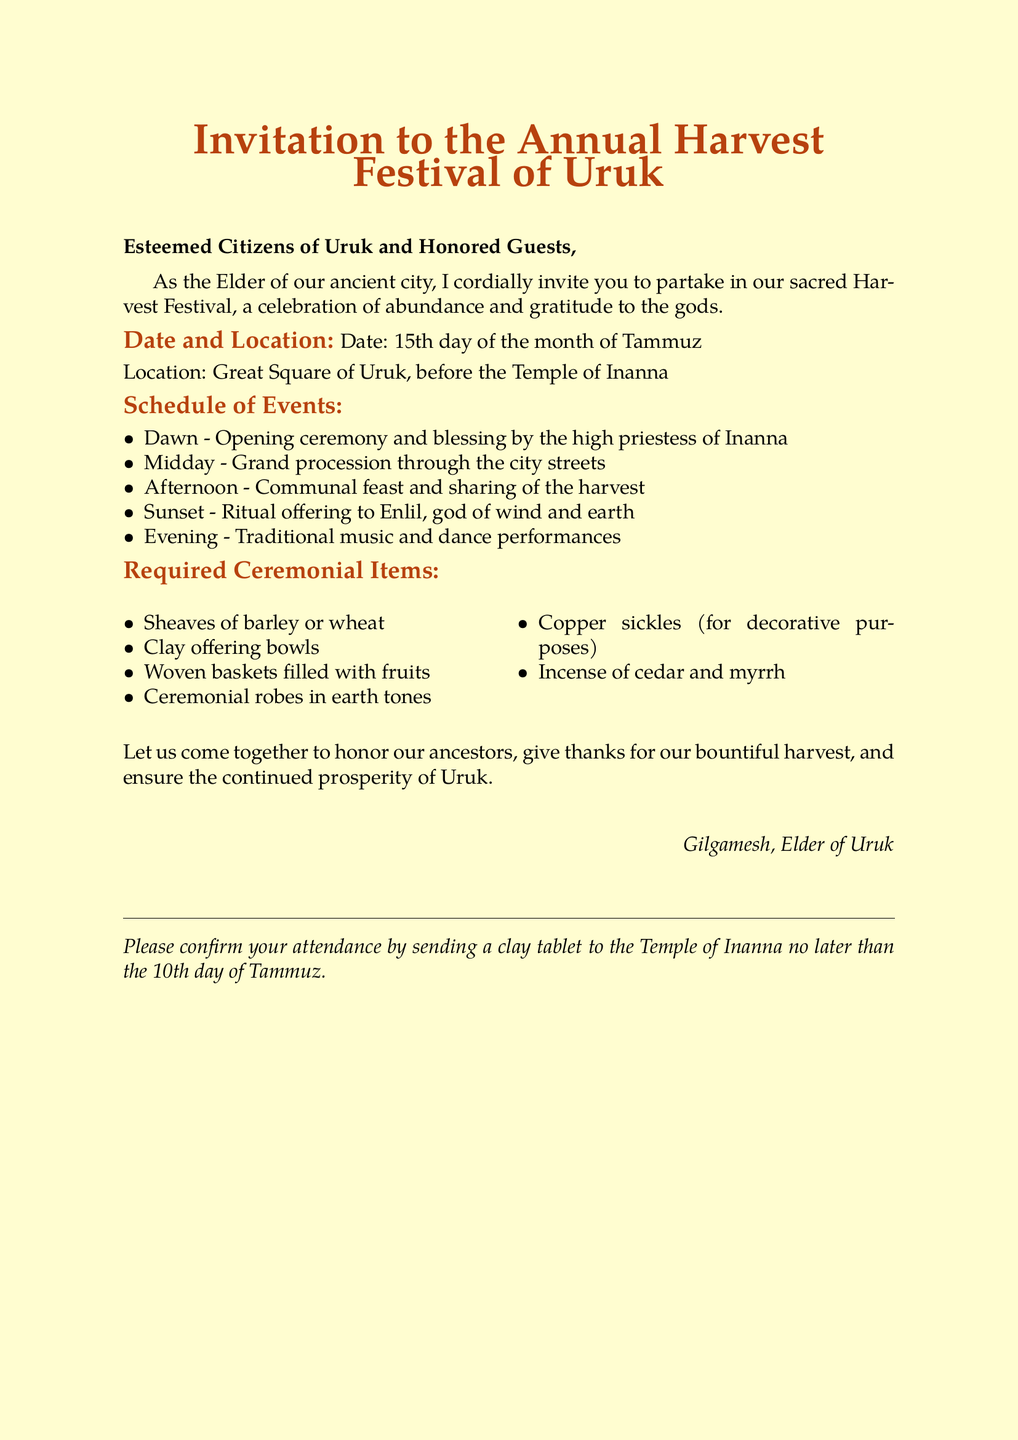What is the date of the Harvest Festival? The date is specifically mentioned in the invitation as the 15th day of the month of Tammuz.
Answer: 15th day of the month of Tammuz Where is the festival taking place? The location is given as the Great Square of Uruk, before the Temple of Inanna.
Answer: Great Square of Uruk, before the Temple of Inanna Who is conducting the opening ceremony? The document states that the opening ceremony and blessing will be conducted by the high priestess of Inanna.
Answer: high priestess of Inanna What type of robes are required for the ceremony? The invitation mentions that ceremonial robes should be in earth tones.
Answer: earth tones What is the last day to confirm attendance? The document specifies that attendees must confirm their attendance by the 10th day of Tammuz.
Answer: 10th day of Tammuz What is offered to Enlil during the festival? The ritual offering to Enlil is mentioned, signifying a specific act during the festival.
Answer: Ritual offering How many ceremonial items are listed in the document? The required ceremonial items are enumerated, allowing for a tally of those listed.
Answer: Six items What type of performances will occur in the evening? The document indicates that traditional music and dance performances will take place.
Answer: Traditional music and dance performances What is the purpose of the Harvest Festival? The invitation describes the festival as a celebration of abundance and gratitude to the gods.
Answer: Gratitude to the gods 